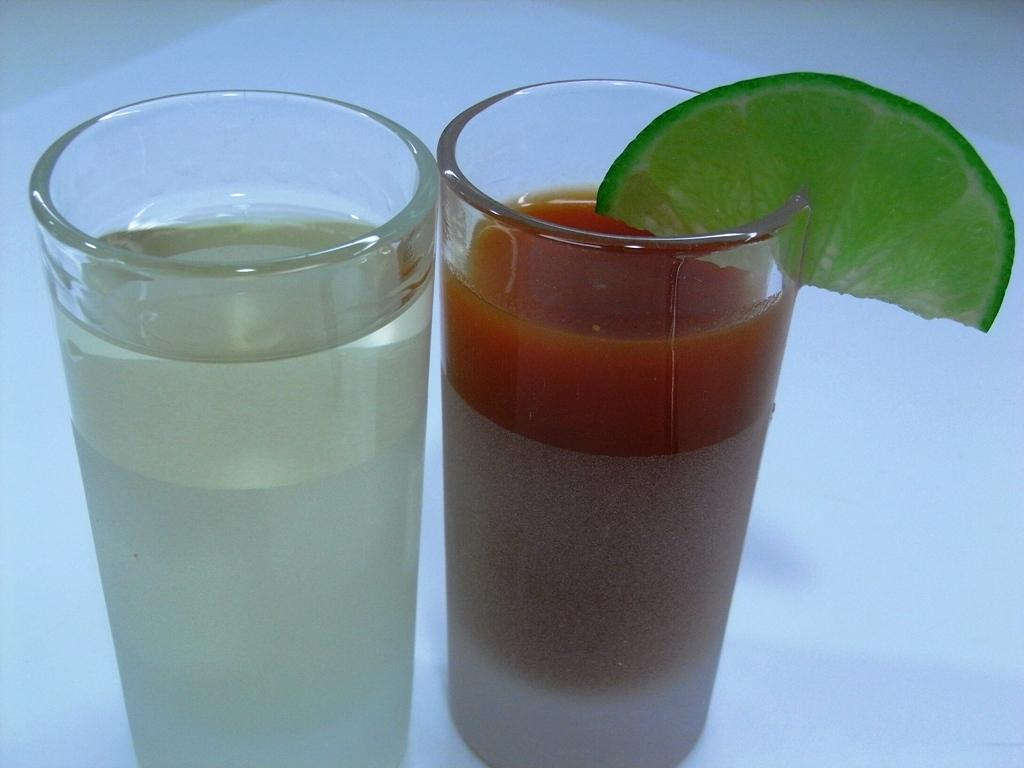What type of glasses can be seen in the image? There are beverage glasses in the image. Can you describe any additional details about the glasses? Yes, there is a lemon wedge on one of the glasses. How many legs can be seen supporting the glasses in the image? There are no legs visible in the image; the glasses are likely resting on a surface. What type of cream is visible in the image? There is no cream present in the image. Is there a nest visible in the image? There is no nest present in the image. 